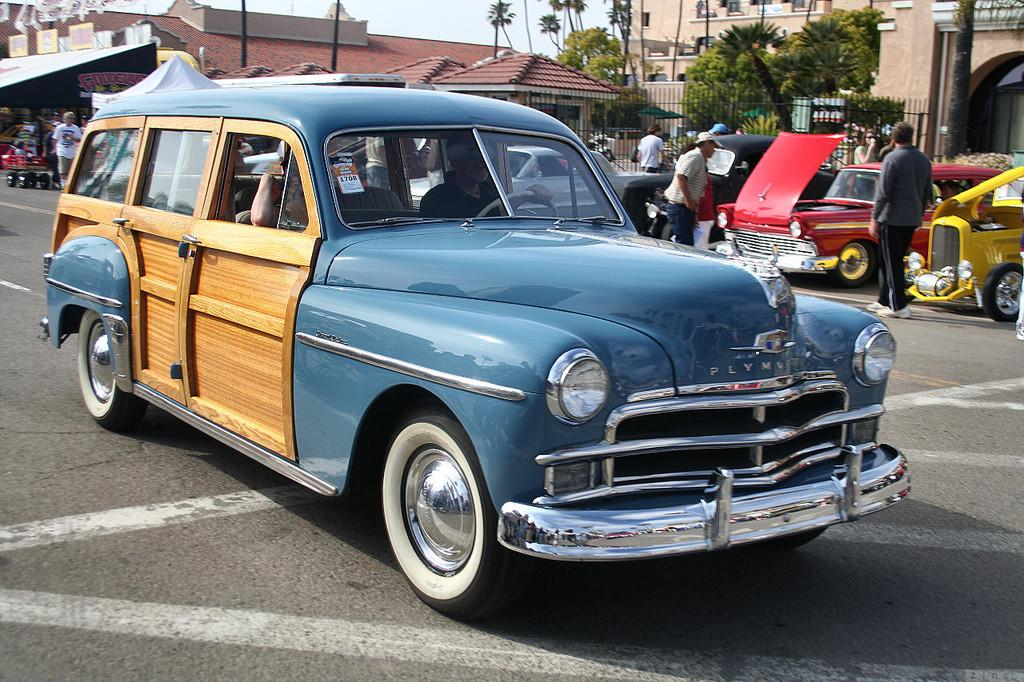What type of vehicles can be seen in the image? There are cars in the image. Can you describe the people in the image? There are people in the image. What can be seen in the background of the image? There are buildings, trees, and the sky visible in the background of the image. What architectural feature is present in the image? There are grilles in the image. Where is the tent located in the image? The tent is on the left side of the image. Can you tell me how many apples are hanging from the grilles in the image? There are no apples present in the image; the grilles are not associated with any fruit. How do the people in the image jump over the cars? There is no jumping activity depicted in the image; the people are not shown performing any such action. 